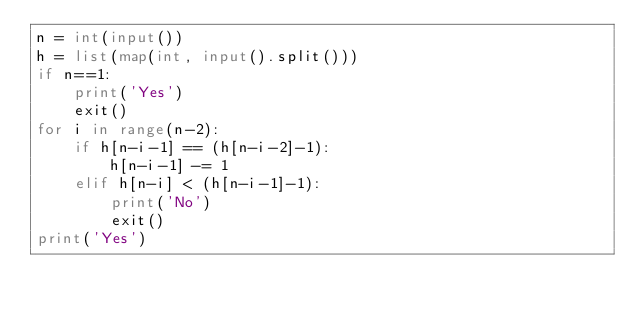<code> <loc_0><loc_0><loc_500><loc_500><_Python_>n = int(input())
h = list(map(int, input().split()))
if n==1:
    print('Yes')
    exit()
for i in range(n-2):
    if h[n-i-1] == (h[n-i-2]-1):
        h[n-i-1] -= 1
    elif h[n-i] < (h[n-i-1]-1):
        print('No')
        exit()
print('Yes')</code> 